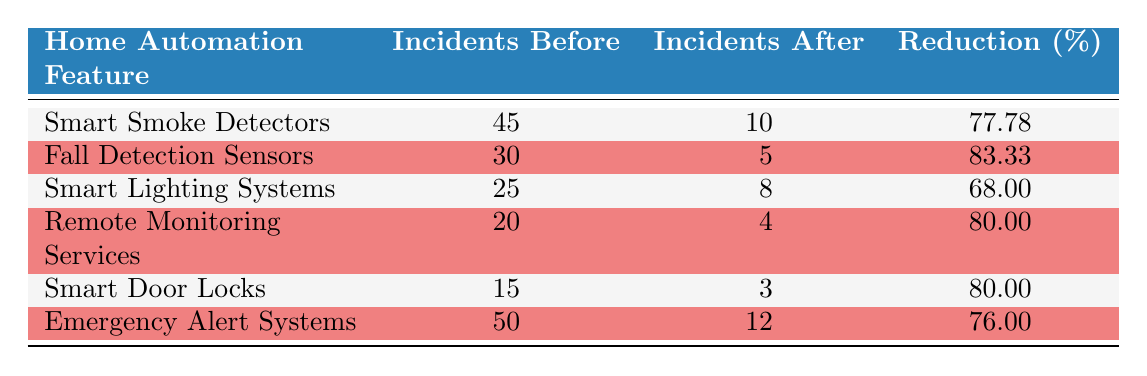What was the percentage reduction in incidents for Smart Smoke Detectors? The table states that the percentage reduction in incidents for Smart Smoke Detectors is 77.78%.
Answer: 77.78% How many incidents were reported before the implementation of Fall Detection Sensors? According to the table, the number of incidents reported before the implementation of Fall Detection Sensors was 30.
Answer: 30 What is the difference in the number of incidents for Remote Monitoring Services before and after implementation? The table shows that incidents before implementation were 20 and after implementation were 4. The difference is 20 - 4 = 16.
Answer: 16 Did Smart Door Locks contribute to a reduction of more than 75% in emergency incidents? The table shows a percentage reduction for Smart Door Locks as 80.00%, which is indeed greater than 75%.
Answer: Yes Which home automation feature had the highest percentage reduction in incidents? By reviewing the percentage reductions in the table, Fall Detection Sensors had the highest percentage reduction at 83.33%.
Answer: Fall Detection Sensors What was the total number of incidents reported before the implementation of all listed home automation features? To find this, we sum the incidents before implementation for all features: 45 + 30 + 25 + 20 + 15 + 50 = 185.
Answer: 185 Was the reduction in emergency incidents for Emergency Alert Systems less than for Smart Lighting Systems? The percentage reduction for Emergency Alert Systems is 76.00%, while Smart Lighting Systems has a reduction of 68.00%. Since 76.00% is greater than 68.00%, the statement is false.
Answer: No What is the average percentage reduction in incidents across all home automation features listed? To find the average, we sum the percentage reductions: (77.78 + 83.33 + 68.00 + 80.00 + 80.00 + 76.00) and divide by the number of features (6). The sum is 465.11, divided by 6 gives an average of approximately 77.52%.
Answer: 77.52% Which feature had the least reduction in emergency incidents? Reviewing the percentage reductions from the table, Smart Lighting Systems had the least reduction at 68.00%.
Answer: Smart Lighting Systems 